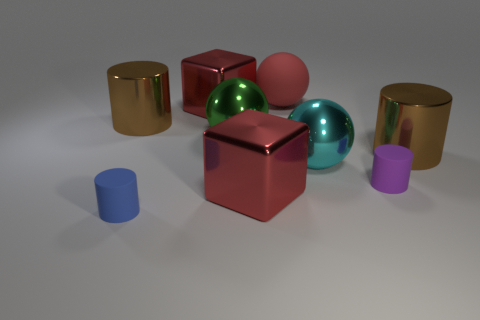Subtract all purple cylinders. How many cylinders are left? 3 Subtract all metallic balls. How many balls are left? 1 Add 1 small purple matte things. How many objects exist? 10 Subtract 1 cylinders. How many cylinders are left? 3 Subtract all cyan cylinders. Subtract all gray balls. How many cylinders are left? 4 Subtract all cylinders. How many objects are left? 5 Add 6 small purple matte things. How many small purple matte things exist? 7 Subtract 1 cyan balls. How many objects are left? 8 Subtract all large objects. Subtract all large blocks. How many objects are left? 0 Add 7 red rubber spheres. How many red rubber spheres are left? 8 